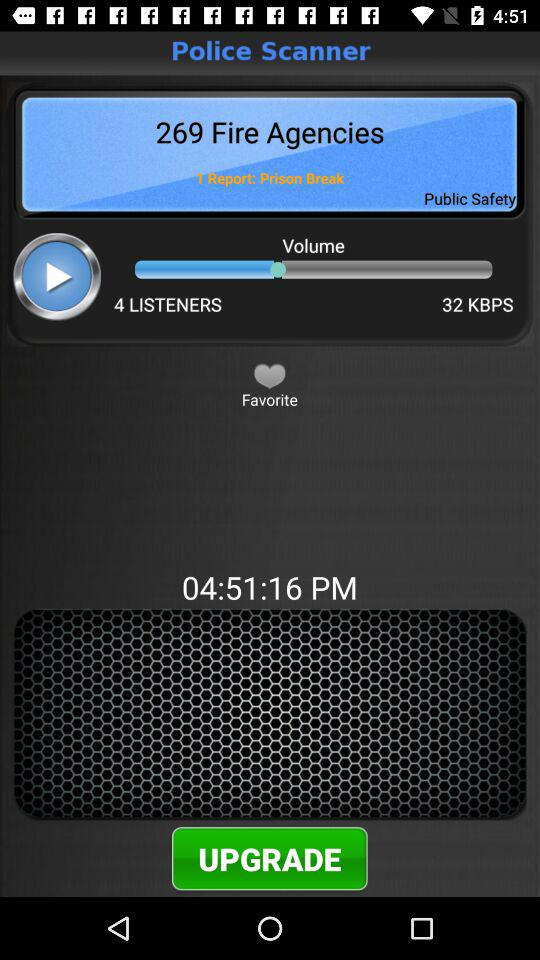What is the speed in KBPS? The speed is 32 KBPS. 